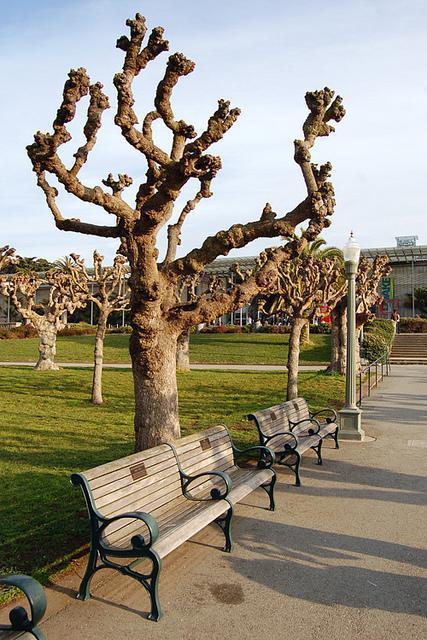How many benches are visible?
Give a very brief answer. 2. How many black dogs are there?
Give a very brief answer. 0. 